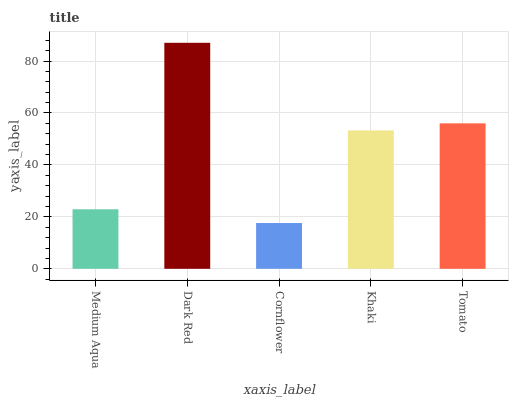Is Cornflower the minimum?
Answer yes or no. Yes. Is Dark Red the maximum?
Answer yes or no. Yes. Is Dark Red the minimum?
Answer yes or no. No. Is Cornflower the maximum?
Answer yes or no. No. Is Dark Red greater than Cornflower?
Answer yes or no. Yes. Is Cornflower less than Dark Red?
Answer yes or no. Yes. Is Cornflower greater than Dark Red?
Answer yes or no. No. Is Dark Red less than Cornflower?
Answer yes or no. No. Is Khaki the high median?
Answer yes or no. Yes. Is Khaki the low median?
Answer yes or no. Yes. Is Dark Red the high median?
Answer yes or no. No. Is Dark Red the low median?
Answer yes or no. No. 